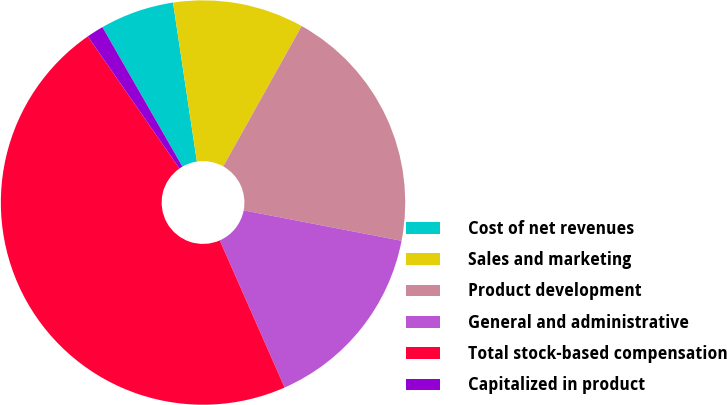Convert chart. <chart><loc_0><loc_0><loc_500><loc_500><pie_chart><fcel>Cost of net revenues<fcel>Sales and marketing<fcel>Product development<fcel>General and administrative<fcel>Total stock-based compensation<fcel>Capitalized in product<nl><fcel>5.92%<fcel>10.48%<fcel>19.92%<fcel>15.36%<fcel>46.96%<fcel>1.36%<nl></chart> 